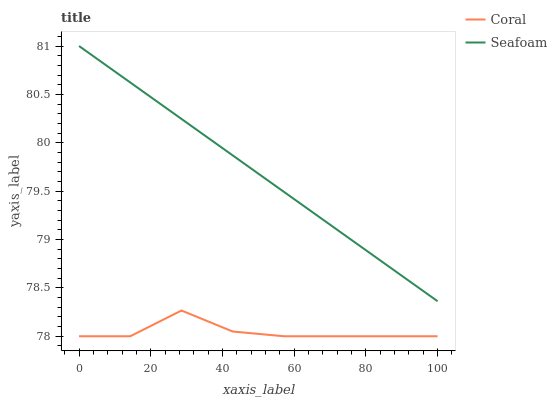Does Seafoam have the minimum area under the curve?
Answer yes or no. No. Is Seafoam the roughest?
Answer yes or no. No. Does Seafoam have the lowest value?
Answer yes or no. No. Is Coral less than Seafoam?
Answer yes or no. Yes. Is Seafoam greater than Coral?
Answer yes or no. Yes. Does Coral intersect Seafoam?
Answer yes or no. No. 